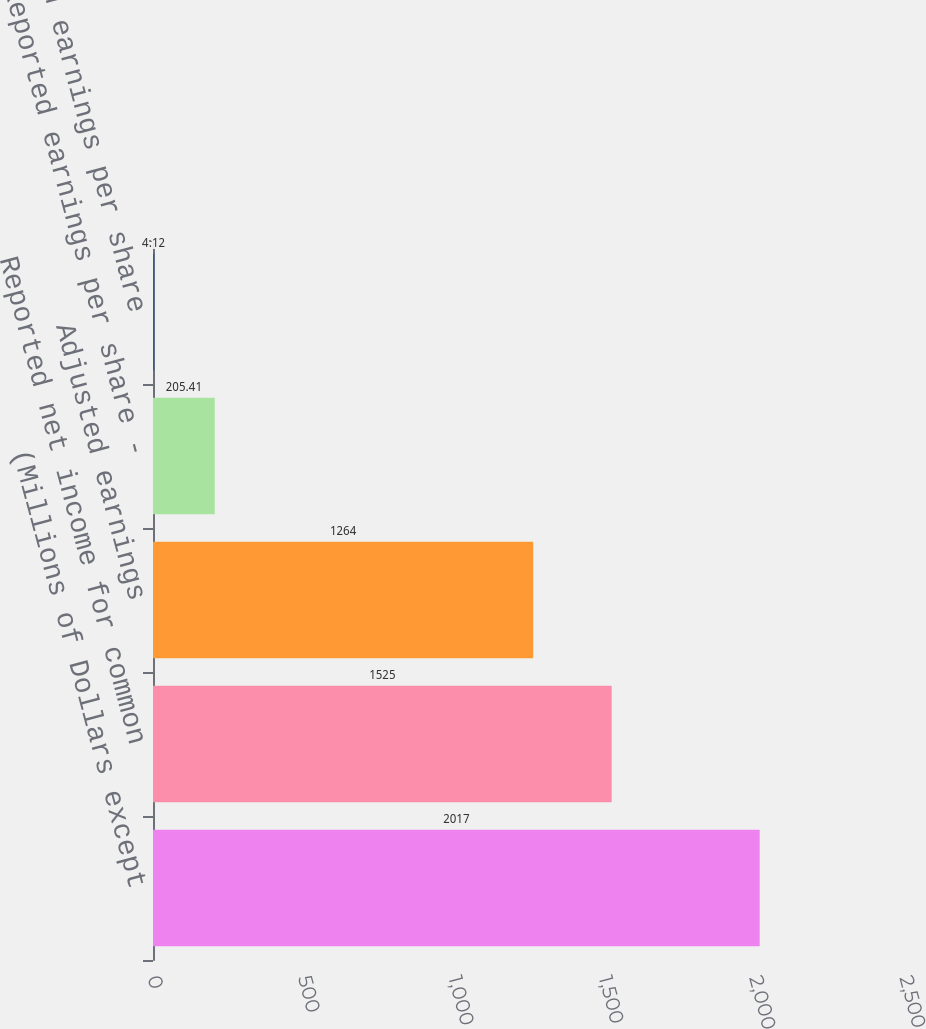Convert chart to OTSL. <chart><loc_0><loc_0><loc_500><loc_500><bar_chart><fcel>(Millions of Dollars except<fcel>Reported net income for common<fcel>Adjusted earnings<fcel>Reported earnings per share -<fcel>Adjusted earnings per share<nl><fcel>2017<fcel>1525<fcel>1264<fcel>205.41<fcel>4.12<nl></chart> 